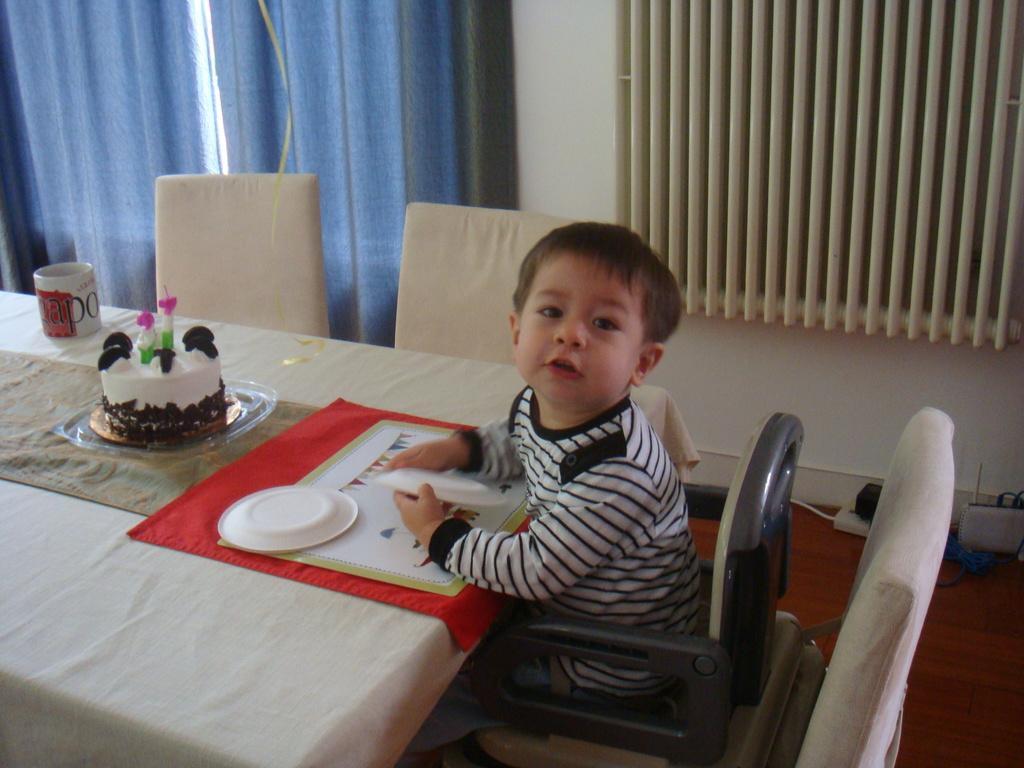Please provide a concise description of this image. The image is inside the room. In the image there is a boy sitting on chair in front of a table, on table we can see a cloth,plate,cake in a tray,cup in background there are curtains and windows. 